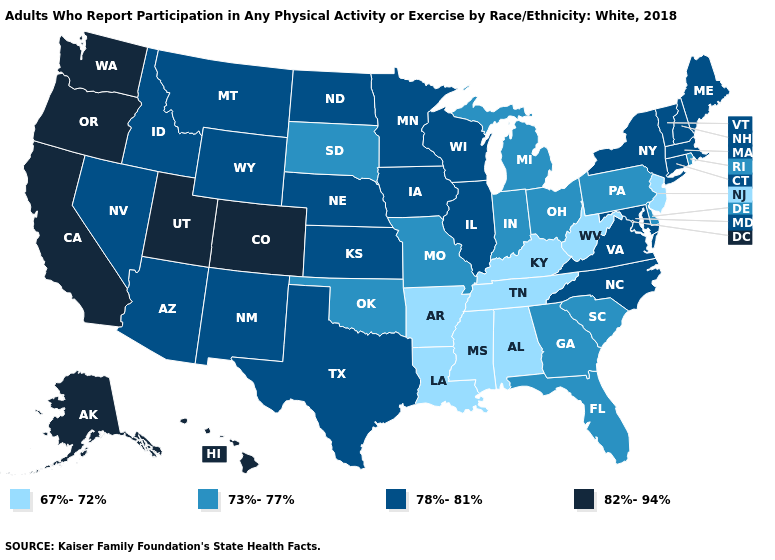Among the states that border Illinois , does Kentucky have the highest value?
Answer briefly. No. Name the states that have a value in the range 78%-81%?
Write a very short answer. Arizona, Connecticut, Idaho, Illinois, Iowa, Kansas, Maine, Maryland, Massachusetts, Minnesota, Montana, Nebraska, Nevada, New Hampshire, New Mexico, New York, North Carolina, North Dakota, Texas, Vermont, Virginia, Wisconsin, Wyoming. Which states have the lowest value in the USA?
Answer briefly. Alabama, Arkansas, Kentucky, Louisiana, Mississippi, New Jersey, Tennessee, West Virginia. Name the states that have a value in the range 82%-94%?
Be succinct. Alaska, California, Colorado, Hawaii, Oregon, Utah, Washington. What is the highest value in the Northeast ?
Answer briefly. 78%-81%. What is the value of Kansas?
Give a very brief answer. 78%-81%. Among the states that border Florida , which have the lowest value?
Keep it brief. Alabama. Which states have the lowest value in the USA?
Concise answer only. Alabama, Arkansas, Kentucky, Louisiana, Mississippi, New Jersey, Tennessee, West Virginia. What is the lowest value in states that border North Dakota?
Concise answer only. 73%-77%. What is the value of Alabama?
Answer briefly. 67%-72%. Among the states that border Louisiana , does Texas have the lowest value?
Concise answer only. No. What is the value of Florida?
Be succinct. 73%-77%. Does Colorado have the highest value in the USA?
Quick response, please. Yes. Among the states that border Alabama , does Mississippi have the highest value?
Be succinct. No. What is the highest value in the South ?
Be succinct. 78%-81%. 